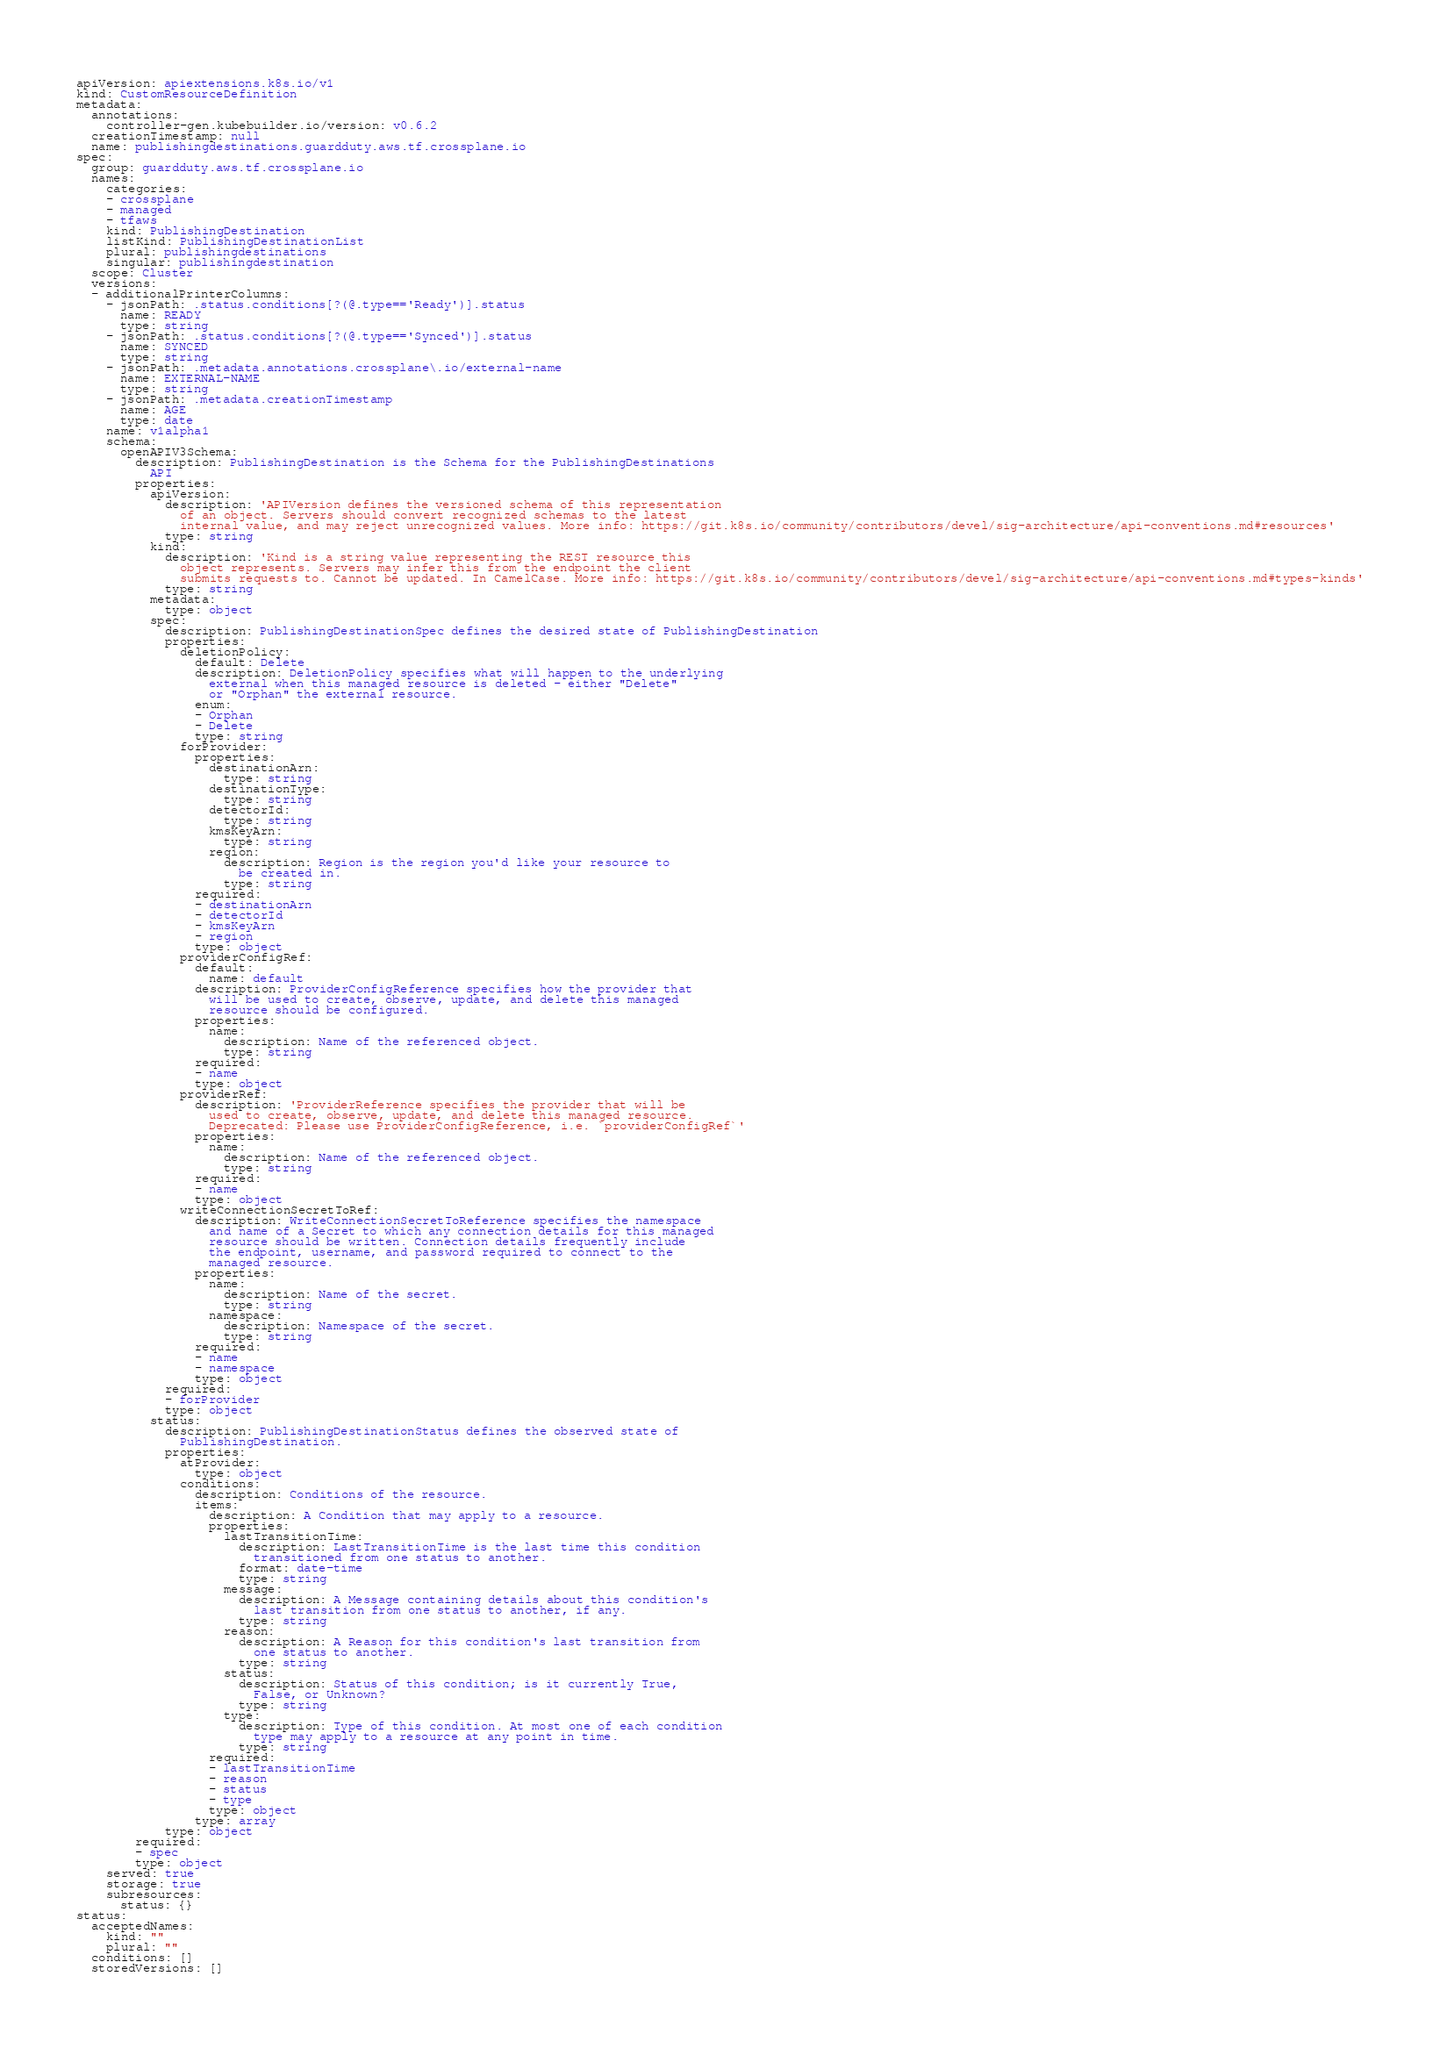Convert code to text. <code><loc_0><loc_0><loc_500><loc_500><_YAML_>apiVersion: apiextensions.k8s.io/v1
kind: CustomResourceDefinition
metadata:
  annotations:
    controller-gen.kubebuilder.io/version: v0.6.2
  creationTimestamp: null
  name: publishingdestinations.guardduty.aws.tf.crossplane.io
spec:
  group: guardduty.aws.tf.crossplane.io
  names:
    categories:
    - crossplane
    - managed
    - tfaws
    kind: PublishingDestination
    listKind: PublishingDestinationList
    plural: publishingdestinations
    singular: publishingdestination
  scope: Cluster
  versions:
  - additionalPrinterColumns:
    - jsonPath: .status.conditions[?(@.type=='Ready')].status
      name: READY
      type: string
    - jsonPath: .status.conditions[?(@.type=='Synced')].status
      name: SYNCED
      type: string
    - jsonPath: .metadata.annotations.crossplane\.io/external-name
      name: EXTERNAL-NAME
      type: string
    - jsonPath: .metadata.creationTimestamp
      name: AGE
      type: date
    name: v1alpha1
    schema:
      openAPIV3Schema:
        description: PublishingDestination is the Schema for the PublishingDestinations
          API
        properties:
          apiVersion:
            description: 'APIVersion defines the versioned schema of this representation
              of an object. Servers should convert recognized schemas to the latest
              internal value, and may reject unrecognized values. More info: https://git.k8s.io/community/contributors/devel/sig-architecture/api-conventions.md#resources'
            type: string
          kind:
            description: 'Kind is a string value representing the REST resource this
              object represents. Servers may infer this from the endpoint the client
              submits requests to. Cannot be updated. In CamelCase. More info: https://git.k8s.io/community/contributors/devel/sig-architecture/api-conventions.md#types-kinds'
            type: string
          metadata:
            type: object
          spec:
            description: PublishingDestinationSpec defines the desired state of PublishingDestination
            properties:
              deletionPolicy:
                default: Delete
                description: DeletionPolicy specifies what will happen to the underlying
                  external when this managed resource is deleted - either "Delete"
                  or "Orphan" the external resource.
                enum:
                - Orphan
                - Delete
                type: string
              forProvider:
                properties:
                  destinationArn:
                    type: string
                  destinationType:
                    type: string
                  detectorId:
                    type: string
                  kmsKeyArn:
                    type: string
                  region:
                    description: Region is the region you'd like your resource to
                      be created in.
                    type: string
                required:
                - destinationArn
                - detectorId
                - kmsKeyArn
                - region
                type: object
              providerConfigRef:
                default:
                  name: default
                description: ProviderConfigReference specifies how the provider that
                  will be used to create, observe, update, and delete this managed
                  resource should be configured.
                properties:
                  name:
                    description: Name of the referenced object.
                    type: string
                required:
                - name
                type: object
              providerRef:
                description: 'ProviderReference specifies the provider that will be
                  used to create, observe, update, and delete this managed resource.
                  Deprecated: Please use ProviderConfigReference, i.e. `providerConfigRef`'
                properties:
                  name:
                    description: Name of the referenced object.
                    type: string
                required:
                - name
                type: object
              writeConnectionSecretToRef:
                description: WriteConnectionSecretToReference specifies the namespace
                  and name of a Secret to which any connection details for this managed
                  resource should be written. Connection details frequently include
                  the endpoint, username, and password required to connect to the
                  managed resource.
                properties:
                  name:
                    description: Name of the secret.
                    type: string
                  namespace:
                    description: Namespace of the secret.
                    type: string
                required:
                - name
                - namespace
                type: object
            required:
            - forProvider
            type: object
          status:
            description: PublishingDestinationStatus defines the observed state of
              PublishingDestination.
            properties:
              atProvider:
                type: object
              conditions:
                description: Conditions of the resource.
                items:
                  description: A Condition that may apply to a resource.
                  properties:
                    lastTransitionTime:
                      description: LastTransitionTime is the last time this condition
                        transitioned from one status to another.
                      format: date-time
                      type: string
                    message:
                      description: A Message containing details about this condition's
                        last transition from one status to another, if any.
                      type: string
                    reason:
                      description: A Reason for this condition's last transition from
                        one status to another.
                      type: string
                    status:
                      description: Status of this condition; is it currently True,
                        False, or Unknown?
                      type: string
                    type:
                      description: Type of this condition. At most one of each condition
                        type may apply to a resource at any point in time.
                      type: string
                  required:
                  - lastTransitionTime
                  - reason
                  - status
                  - type
                  type: object
                type: array
            type: object
        required:
        - spec
        type: object
    served: true
    storage: true
    subresources:
      status: {}
status:
  acceptedNames:
    kind: ""
    plural: ""
  conditions: []
  storedVersions: []
</code> 